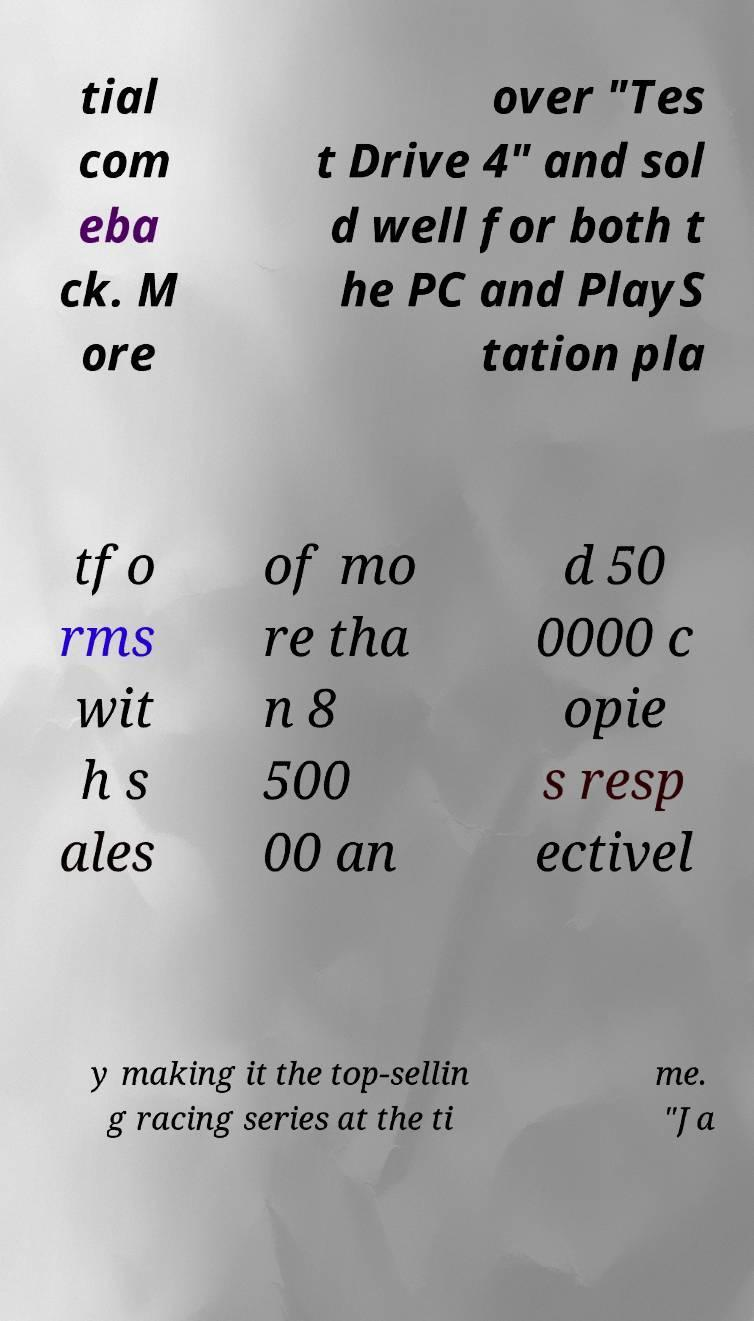For documentation purposes, I need the text within this image transcribed. Could you provide that? tial com eba ck. M ore over "Tes t Drive 4" and sol d well for both t he PC and PlayS tation pla tfo rms wit h s ales of mo re tha n 8 500 00 an d 50 0000 c opie s resp ectivel y making it the top-sellin g racing series at the ti me. "Ja 